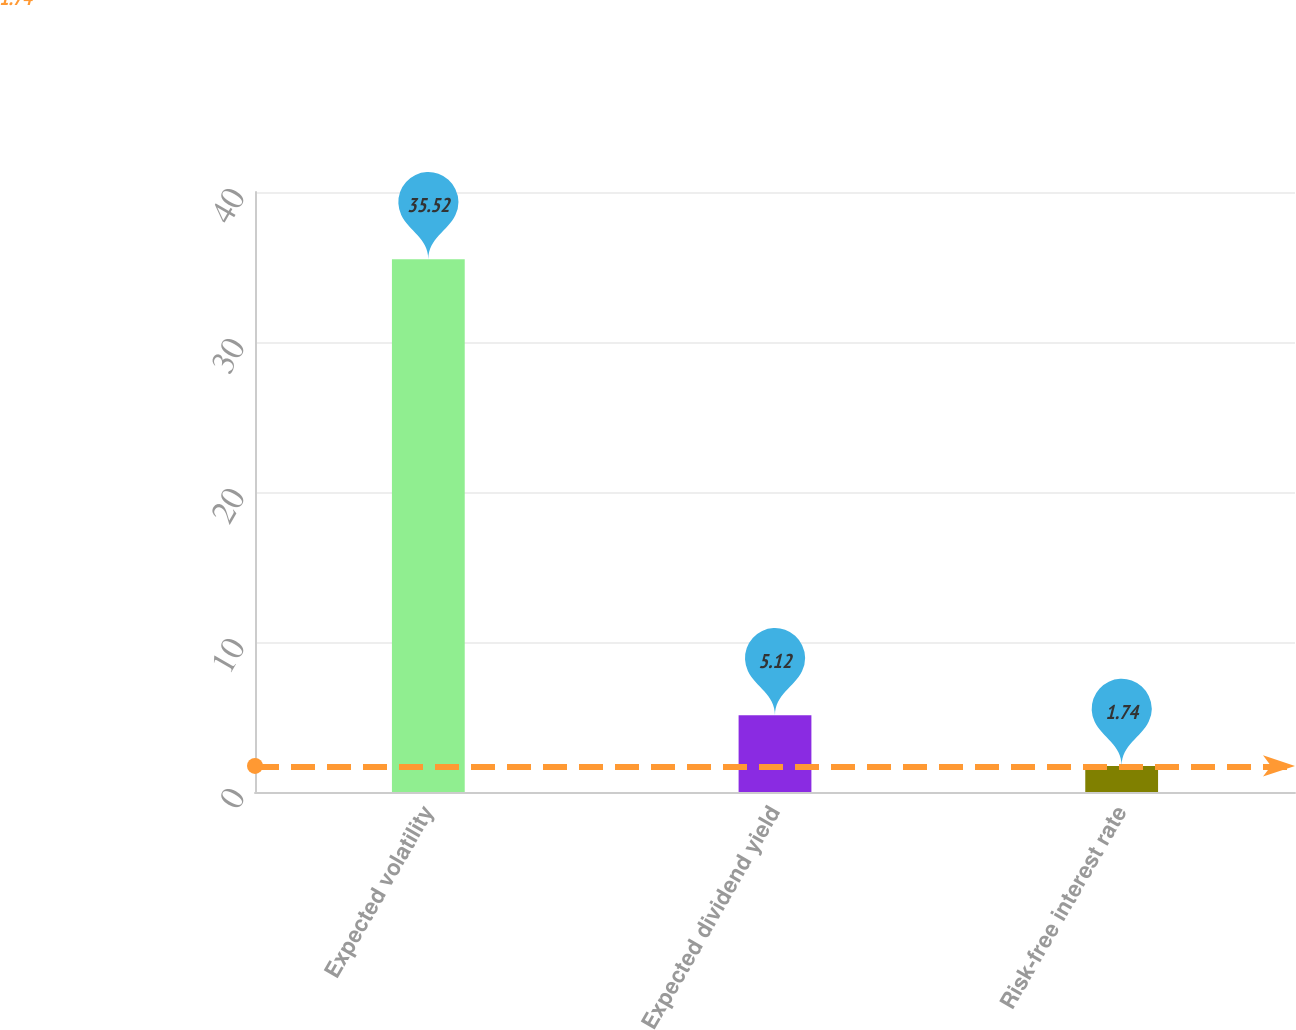Convert chart to OTSL. <chart><loc_0><loc_0><loc_500><loc_500><bar_chart><fcel>Expected volatility<fcel>Expected dividend yield<fcel>Risk-free interest rate<nl><fcel>35.52<fcel>5.12<fcel>1.74<nl></chart> 